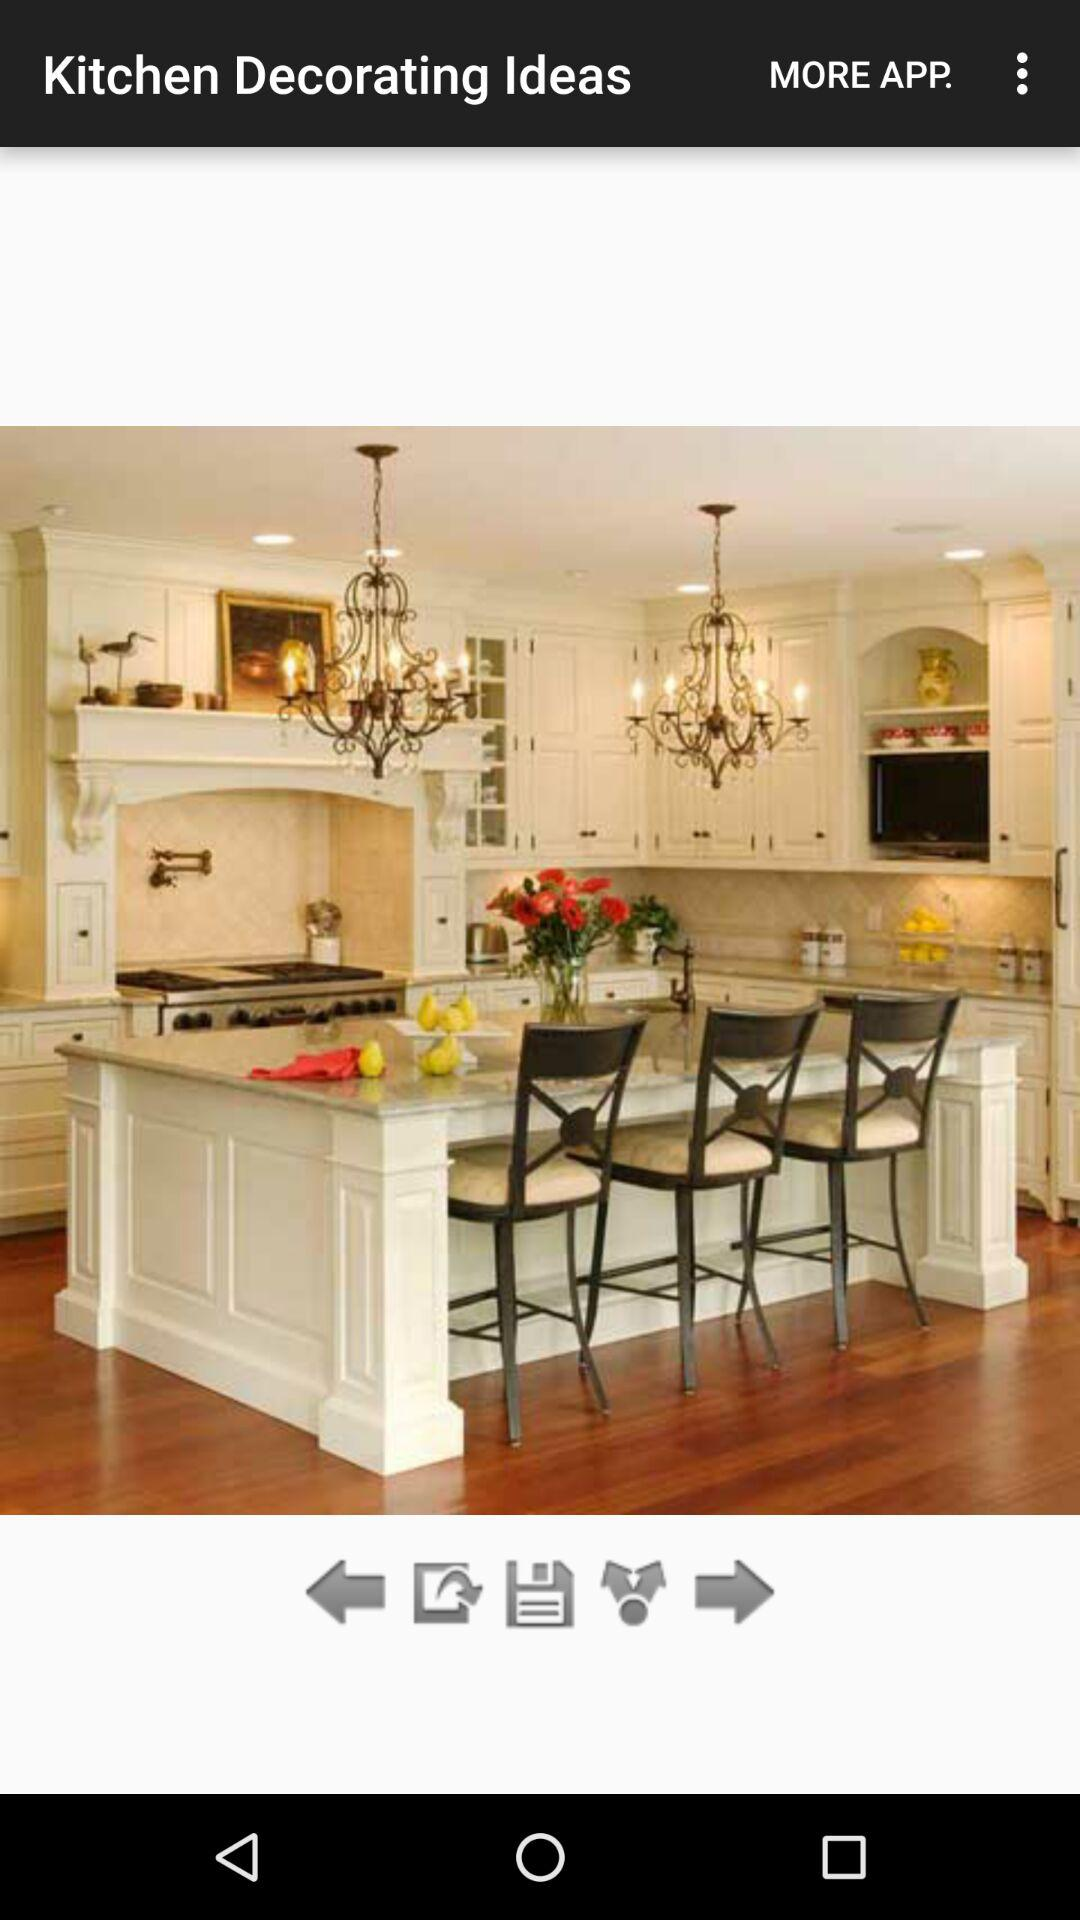What is the name of the application? The name of the application is "Kitchen Decorating Ideas". 